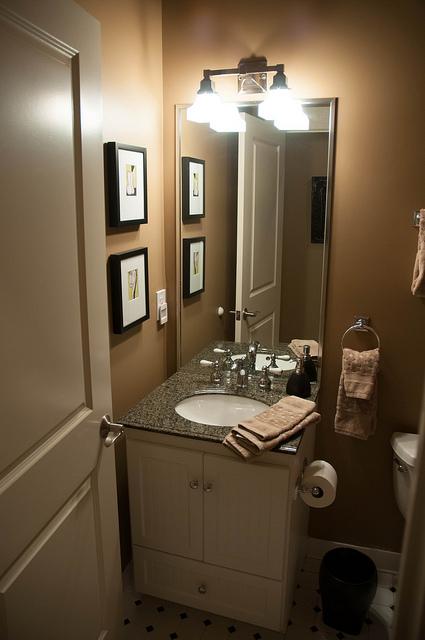Is this a public bathroom?
Write a very short answer. No. What piece of furniture is on the other side of the door?
Answer briefly. Vanity. What color is the towel on the tub?
Keep it brief. Tan. Is the toilet paper folded for presentation?
Give a very brief answer. No. What kind of room is shown?
Write a very short answer. Bathroom. Would you use this bathroom?
Short answer required. Yes. Is this a narrow room?
Short answer required. Yes. Is this a large bathroom?
Be succinct. No. How many towels can be seen?
Keep it brief. 4. Does the mirror have a golden frame?
Be succinct. No. 